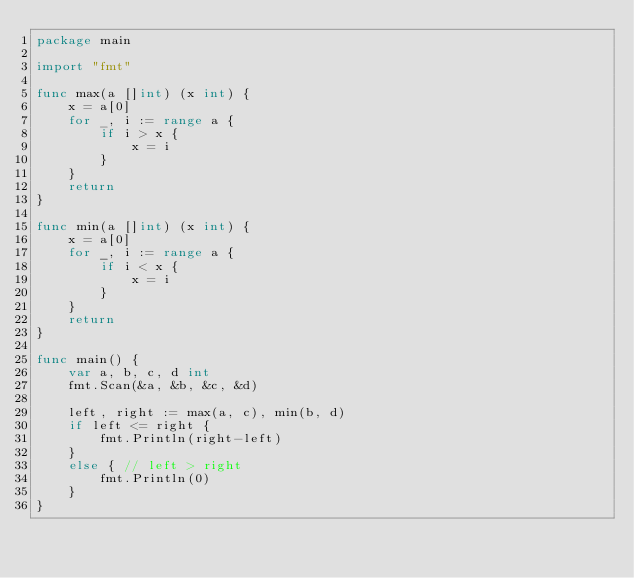Convert code to text. <code><loc_0><loc_0><loc_500><loc_500><_Go_>package main

import "fmt"

func max(a []int) (x int) {
	x = a[0]
	for _, i := range a {
		if i > x {
			x = i
		}
	}
	return
}

func min(a []int) (x int) {
	x = a[0]
	for _, i := range a {
		if i < x {
			x = i
		}
	}
	return
}

func main() {
	var a, b, c, d int
	fmt.Scan(&a, &b, &c, &d)

	left, right := max(a, c), min(b, d)
	if left <= right {
		fmt.Println(right-left)
	}
	else { // left > right
		fmt.Println(0)
	}
}
</code> 